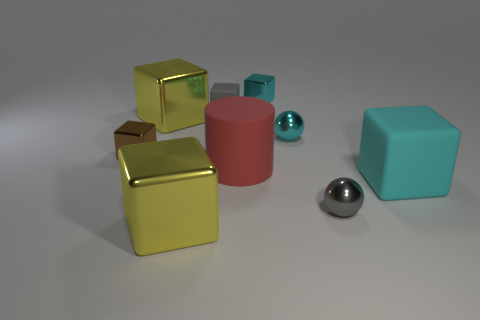Subtract all yellow blocks. How many blocks are left? 4 Subtract all big yellow shiny cubes. How many cubes are left? 4 Subtract all gray blocks. Subtract all red cylinders. How many blocks are left? 5 Subtract all green cubes. How many purple spheres are left? 0 Subtract all small brown shiny cylinders. Subtract all large red cylinders. How many objects are left? 8 Add 5 big cylinders. How many big cylinders are left? 6 Add 1 small rubber objects. How many small rubber objects exist? 2 Subtract 0 purple balls. How many objects are left? 9 Subtract all cubes. How many objects are left? 3 Subtract 1 cylinders. How many cylinders are left? 0 